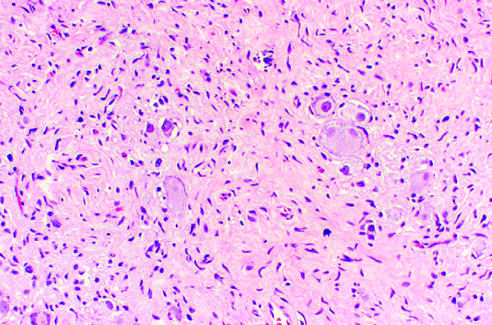what are ganglioneuromas characterized by?
Answer the question using a single word or phrase. Clusters of large ganglion cells with vesicular nuclei and abundant eosinophilic cytoplasm 